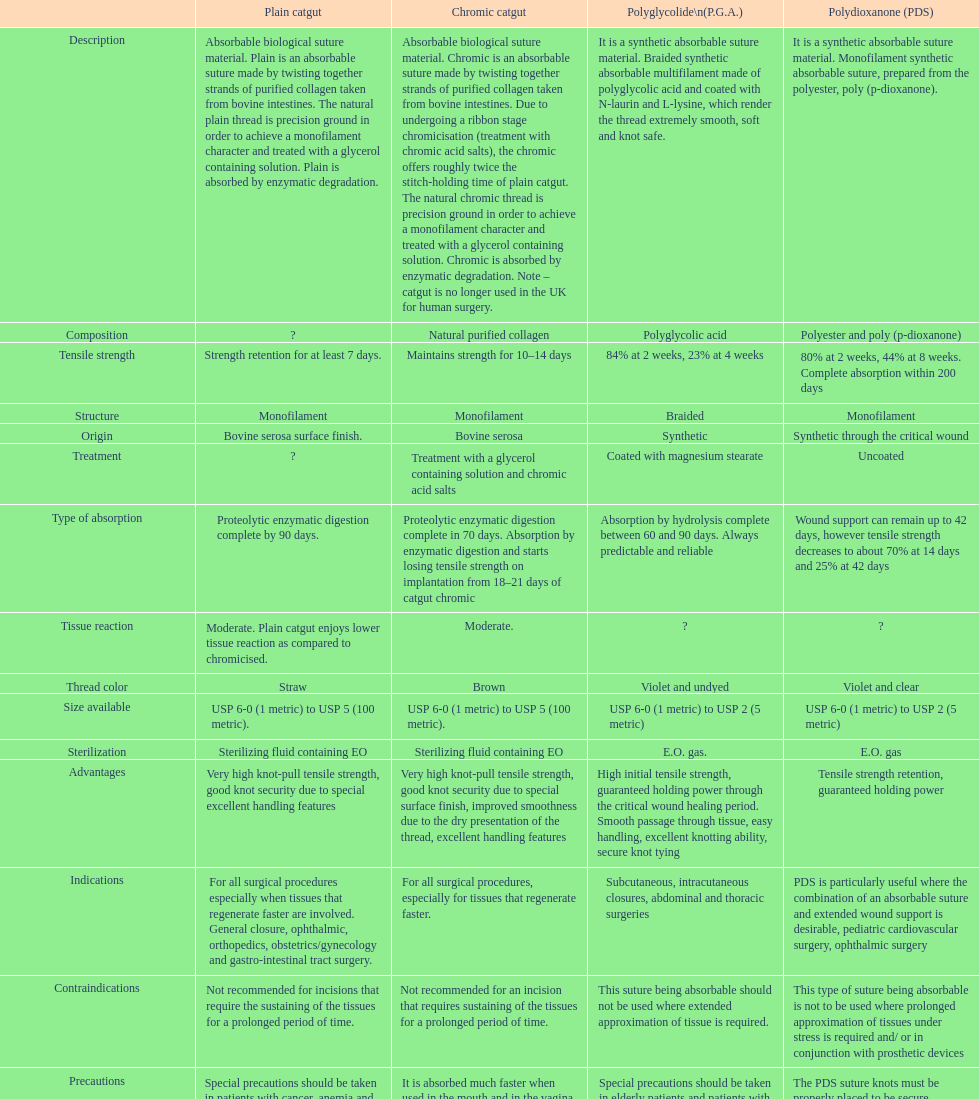What sort of sutures are no longer employed in the u.k. for human surgical procedures? Chromic catgut. Help me parse the entirety of this table. {'header': ['', 'Plain catgut', 'Chromic catgut', 'Polyglycolide\\n(P.G.A.)', 'Polydioxanone (PDS)'], 'rows': [['Description', 'Absorbable biological suture material. Plain is an absorbable suture made by twisting together strands of purified collagen taken from bovine intestines. The natural plain thread is precision ground in order to achieve a monofilament character and treated with a glycerol containing solution. Plain is absorbed by enzymatic degradation.', 'Absorbable biological suture material. Chromic is an absorbable suture made by twisting together strands of purified collagen taken from bovine intestines. Due to undergoing a ribbon stage chromicisation (treatment with chromic acid salts), the chromic offers roughly twice the stitch-holding time of plain catgut. The natural chromic thread is precision ground in order to achieve a monofilament character and treated with a glycerol containing solution. Chromic is absorbed by enzymatic degradation. Note – catgut is no longer used in the UK for human surgery.', 'It is a synthetic absorbable suture material. Braided synthetic absorbable multifilament made of polyglycolic acid and coated with N-laurin and L-lysine, which render the thread extremely smooth, soft and knot safe.', 'It is a synthetic absorbable suture material. Monofilament synthetic absorbable suture, prepared from the polyester, poly (p-dioxanone).'], ['Composition', '?', 'Natural purified collagen', 'Polyglycolic acid', 'Polyester and poly (p-dioxanone)'], ['Tensile strength', 'Strength retention for at least 7 days.', 'Maintains strength for 10–14 days', '84% at 2 weeks, 23% at 4 weeks', '80% at 2 weeks, 44% at 8 weeks. Complete absorption within 200 days'], ['Structure', 'Monofilament', 'Monofilament', 'Braided', 'Monofilament'], ['Origin', 'Bovine serosa surface finish.', 'Bovine serosa', 'Synthetic', 'Synthetic through the critical wound'], ['Treatment', '?', 'Treatment with a glycerol containing solution and chromic acid salts', 'Coated with magnesium stearate', 'Uncoated'], ['Type of absorption', 'Proteolytic enzymatic digestion complete by 90 days.', 'Proteolytic enzymatic digestion complete in 70 days. Absorption by enzymatic digestion and starts losing tensile strength on implantation from 18–21 days of catgut chromic', 'Absorption by hydrolysis complete between 60 and 90 days. Always predictable and reliable', 'Wound support can remain up to 42 days, however tensile strength decreases to about 70% at 14 days and 25% at 42 days'], ['Tissue reaction', 'Moderate. Plain catgut enjoys lower tissue reaction as compared to chromicised.', 'Moderate.', '?', '?'], ['Thread color', 'Straw', 'Brown', 'Violet and undyed', 'Violet and clear'], ['Size available', 'USP 6-0 (1 metric) to USP 5 (100 metric).', 'USP 6-0 (1 metric) to USP 5 (100 metric).', 'USP 6-0 (1 metric) to USP 2 (5 metric)', 'USP 6-0 (1 metric) to USP 2 (5 metric)'], ['Sterilization', 'Sterilizing fluid containing EO', 'Sterilizing fluid containing EO', 'E.O. gas.', 'E.O. gas'], ['Advantages', 'Very high knot-pull tensile strength, good knot security due to special excellent handling features', 'Very high knot-pull tensile strength, good knot security due to special surface finish, improved smoothness due to the dry presentation of the thread, excellent handling features', 'High initial tensile strength, guaranteed holding power through the critical wound healing period. Smooth passage through tissue, easy handling, excellent knotting ability, secure knot tying', 'Tensile strength retention, guaranteed holding power'], ['Indications', 'For all surgical procedures especially when tissues that regenerate faster are involved. General closure, ophthalmic, orthopedics, obstetrics/gynecology and gastro-intestinal tract surgery.', 'For all surgical procedures, especially for tissues that regenerate faster.', 'Subcutaneous, intracutaneous closures, abdominal and thoracic surgeries', 'PDS is particularly useful where the combination of an absorbable suture and extended wound support is desirable, pediatric cardiovascular surgery, ophthalmic surgery'], ['Contraindications', 'Not recommended for incisions that require the sustaining of the tissues for a prolonged period of time.', 'Not recommended for an incision that requires sustaining of the tissues for a prolonged period of time.', 'This suture being absorbable should not be used where extended approximation of tissue is required.', 'This type of suture being absorbable is not to be used where prolonged approximation of tissues under stress is required and/ or in conjunction with prosthetic devices'], ['Precautions', 'Special precautions should be taken in patients with cancer, anemia and malnutrition conditions. They tend to absorb the sutures at a higher rate. Cardiovascular surgery, due to the continued heart contractions. It is absorbed much faster when used in the mouth and in the vagina, due to the presence of microorganisms. Avoid using where long term tissue approximation is needed. Absorption is faster in infected tissues', 'It is absorbed much faster when used in the mouth and in the vagina, due to the presence of microorganism. Cardiovascular surgery, due to the continued heart contractions. Special precautions should be taken in patients with cancer, anemia and malnutrition conditions. They tend to absorb this suture at a higher rate.', 'Special precautions should be taken in elderly patients and patients with history of anemia and malnutrition conditions. As with any suture material, adequate knot security requires the accepted surgical technique of flat and square ties.', 'The PDS suture knots must be properly placed to be secure. Conjunctival and vaginal mucosal sutures remaining in place for extended periods may be associated with localized irritation. Subcuticular sutures should be placed as deeply as possible in order to minimize the erythema and induration normally associated with absorption.']]} 